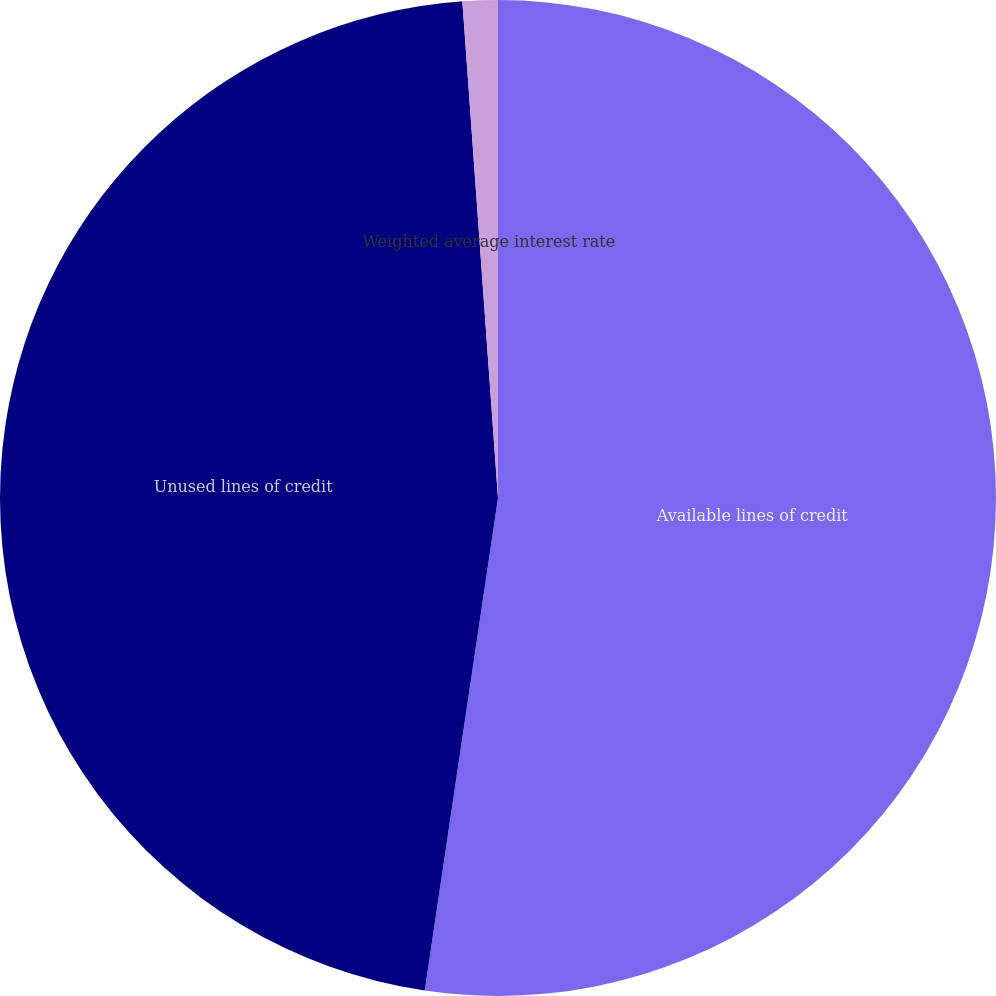Convert chart. <chart><loc_0><loc_0><loc_500><loc_500><pie_chart><fcel>Available lines of credit<fcel>Unused lines of credit<fcel>Weighted average interest rate<nl><fcel>52.35%<fcel>46.51%<fcel>1.14%<nl></chart> 